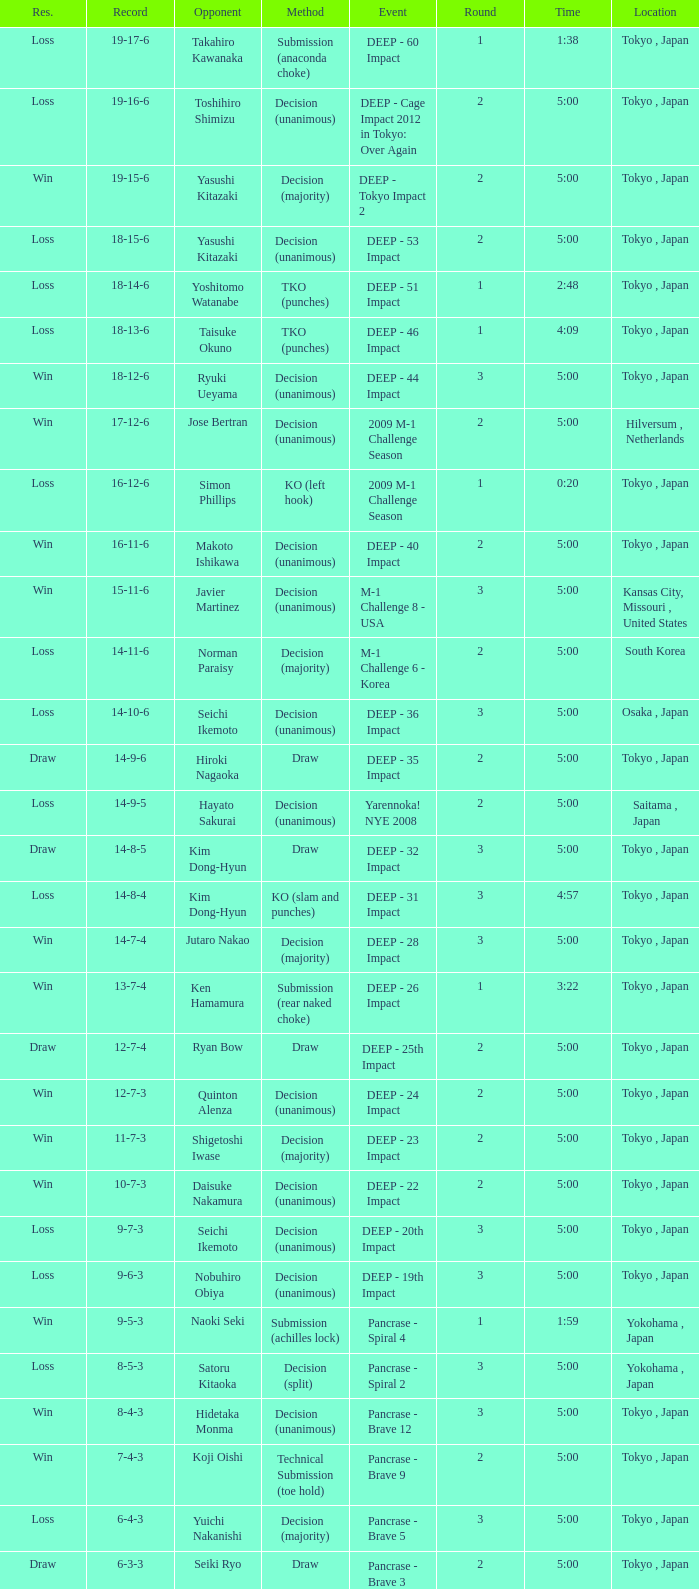What is the site when the record shows 5 wins, 1 loss, and 1 draw? Osaka , Japan. 